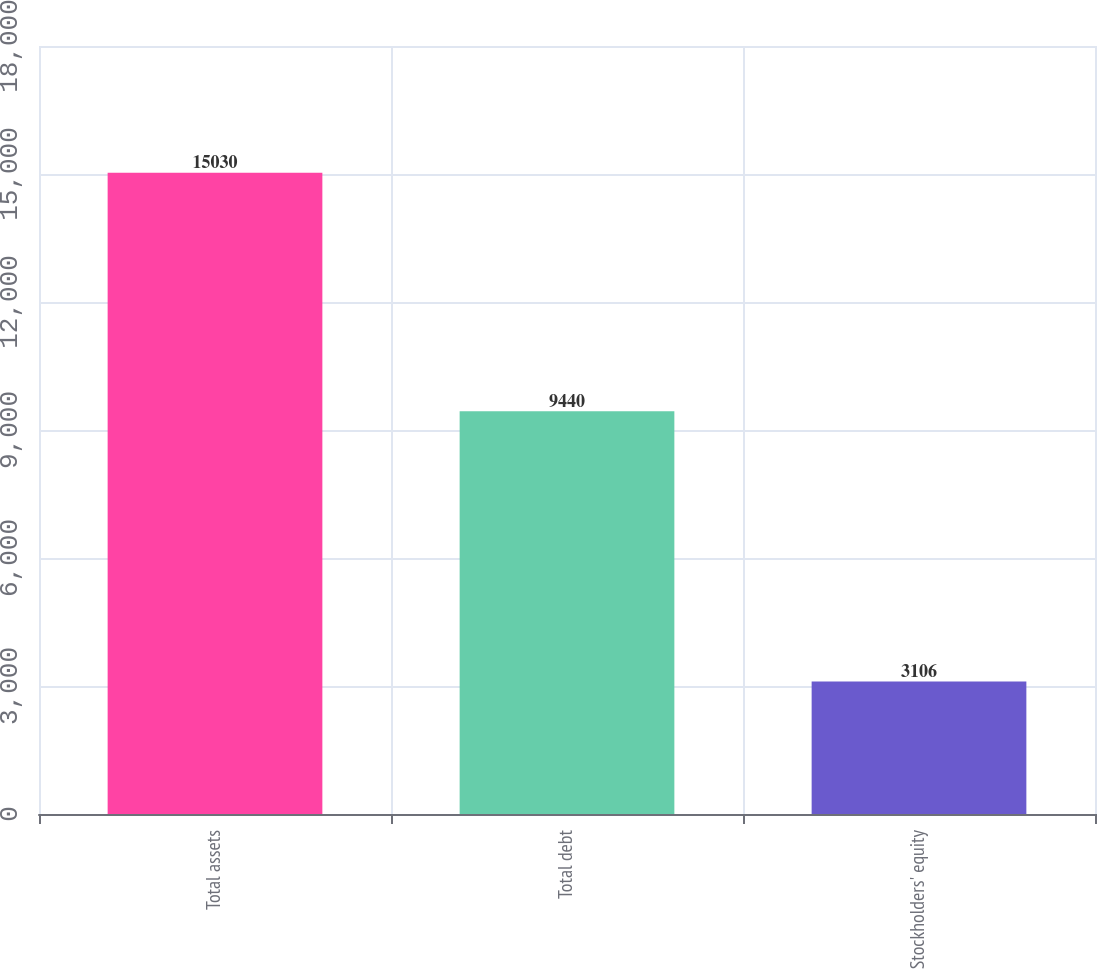<chart> <loc_0><loc_0><loc_500><loc_500><bar_chart><fcel>Total assets<fcel>Total debt<fcel>Stockholders' equity<nl><fcel>15030<fcel>9440<fcel>3106<nl></chart> 